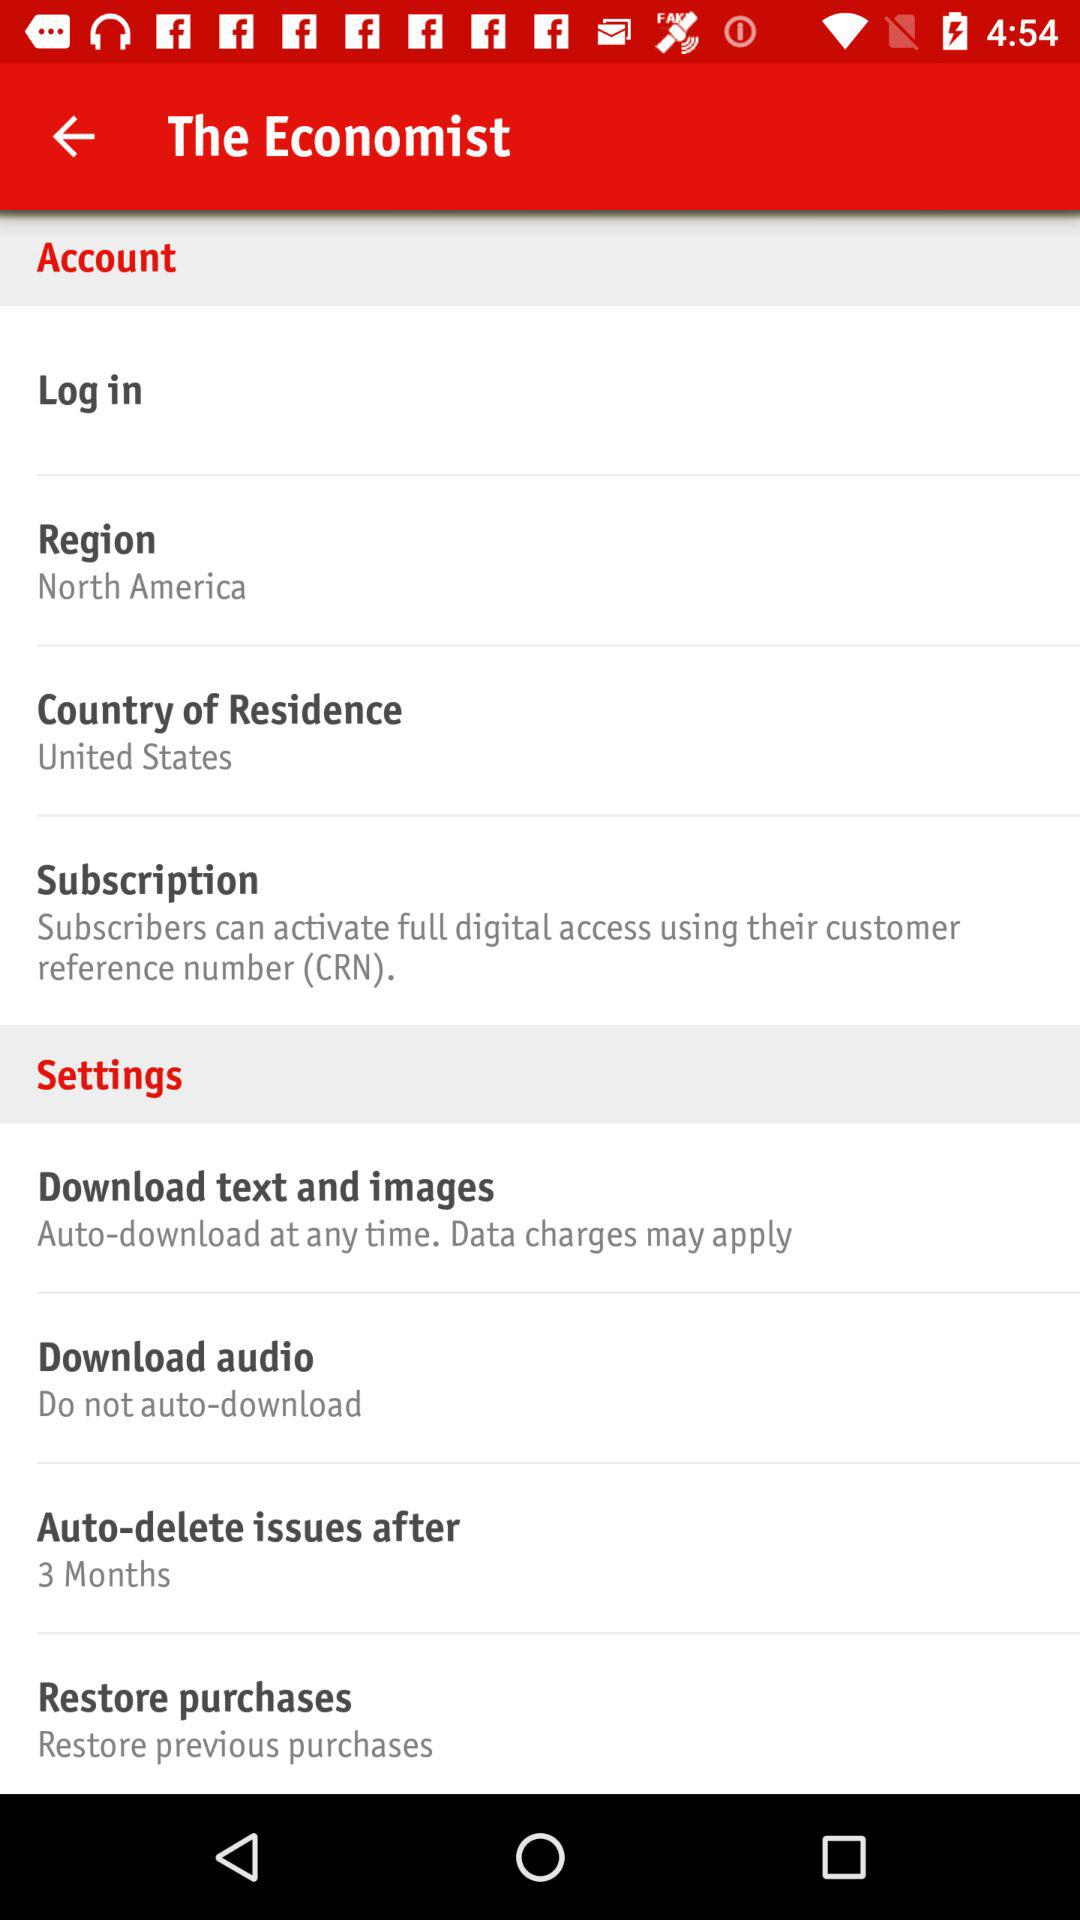What is the application name? The application name is "The Economist". 